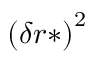Convert formula to latex. <formula><loc_0><loc_0><loc_500><loc_500>\left ( \delta r * \right ) ^ { 2 }</formula> 